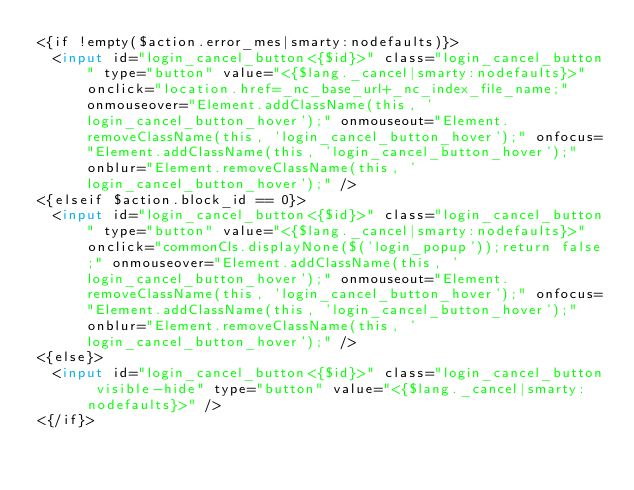Convert code to text. <code><loc_0><loc_0><loc_500><loc_500><_HTML_><{if !empty($action.error_mes|smarty:nodefaults)}>
	<input id="login_cancel_button<{$id}>" class="login_cancel_button" type="button" value="<{$lang._cancel|smarty:nodefaults}>" onclick="location.href=_nc_base_url+_nc_index_file_name;" onmouseover="Element.addClassName(this, 'login_cancel_button_hover');" onmouseout="Element.removeClassName(this, 'login_cancel_button_hover');" onfocus="Element.addClassName(this, 'login_cancel_button_hover');" onblur="Element.removeClassName(this, 'login_cancel_button_hover');" />
<{elseif $action.block_id == 0}>
	<input id="login_cancel_button<{$id}>" class="login_cancel_button" type="button" value="<{$lang._cancel|smarty:nodefaults}>" onclick="commonCls.displayNone($('login_popup'));return false;" onmouseover="Element.addClassName(this, 'login_cancel_button_hover');" onmouseout="Element.removeClassName(this, 'login_cancel_button_hover');" onfocus="Element.addClassName(this, 'login_cancel_button_hover');" onblur="Element.removeClassName(this, 'login_cancel_button_hover');" />
<{else}>
	<input id="login_cancel_button<{$id}>" class="login_cancel_button visible-hide" type="button" value="<{$lang._cancel|smarty:nodefaults}>" />
<{/if}></code> 